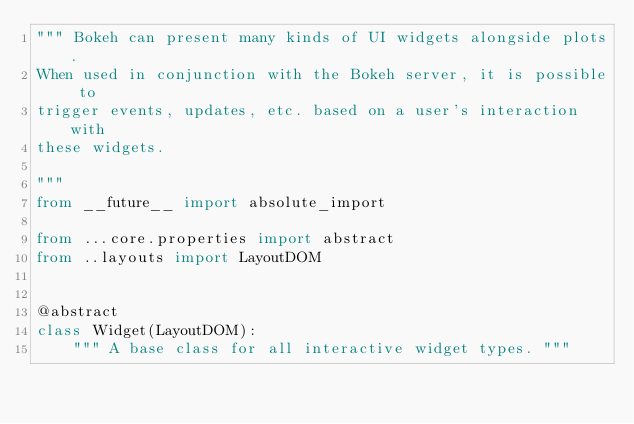Convert code to text. <code><loc_0><loc_0><loc_500><loc_500><_Python_>""" Bokeh can present many kinds of UI widgets alongside plots.
When used in conjunction with the Bokeh server, it is possible to
trigger events, updates, etc. based on a user's interaction with
these widgets.

"""
from __future__ import absolute_import

from ...core.properties import abstract
from ..layouts import LayoutDOM


@abstract
class Widget(LayoutDOM):
    """ A base class for all interactive widget types. """
</code> 